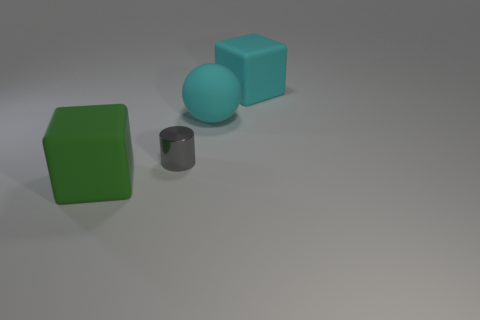What number of other things are there of the same shape as the green thing?
Offer a terse response. 1. Does the cube that is on the right side of the cyan sphere have the same size as the tiny gray cylinder?
Make the answer very short. No. There is a sphere; is it the same color as the large block on the right side of the metallic cylinder?
Make the answer very short. Yes. What is the shape of the thing that is the same color as the ball?
Make the answer very short. Cube. The big green object is what shape?
Make the answer very short. Cube. How many things are large rubber things that are in front of the metal cylinder or big objects?
Offer a very short reply. 3. What size is the green object that is made of the same material as the sphere?
Your response must be concise. Large. Is the number of metal cylinders in front of the ball greater than the number of tiny cyan blocks?
Offer a very short reply. Yes. There is a green rubber thing; is it the same shape as the gray metallic object that is on the left side of the big cyan rubber block?
Keep it short and to the point. No. How many small objects are either gray objects or cyan cubes?
Offer a terse response. 1. 